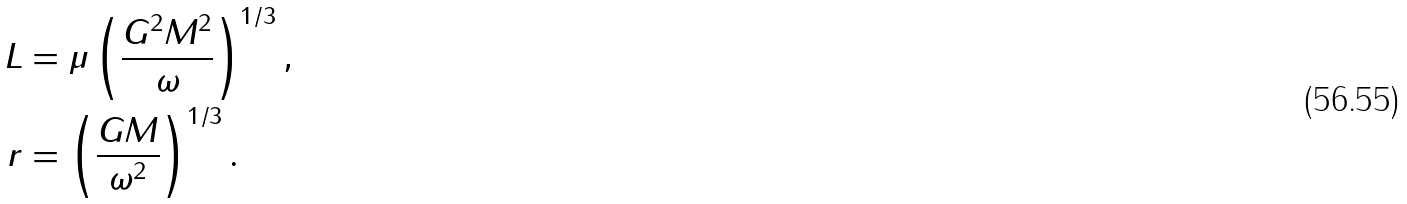Convert formula to latex. <formula><loc_0><loc_0><loc_500><loc_500>L & = \mu \left ( \frac { G ^ { 2 } M ^ { 2 } } { \omega } \right ) ^ { 1 / 3 } , \\ r & = \left ( \frac { G M } { \omega ^ { 2 } } \right ) ^ { 1 / 3 } .</formula> 